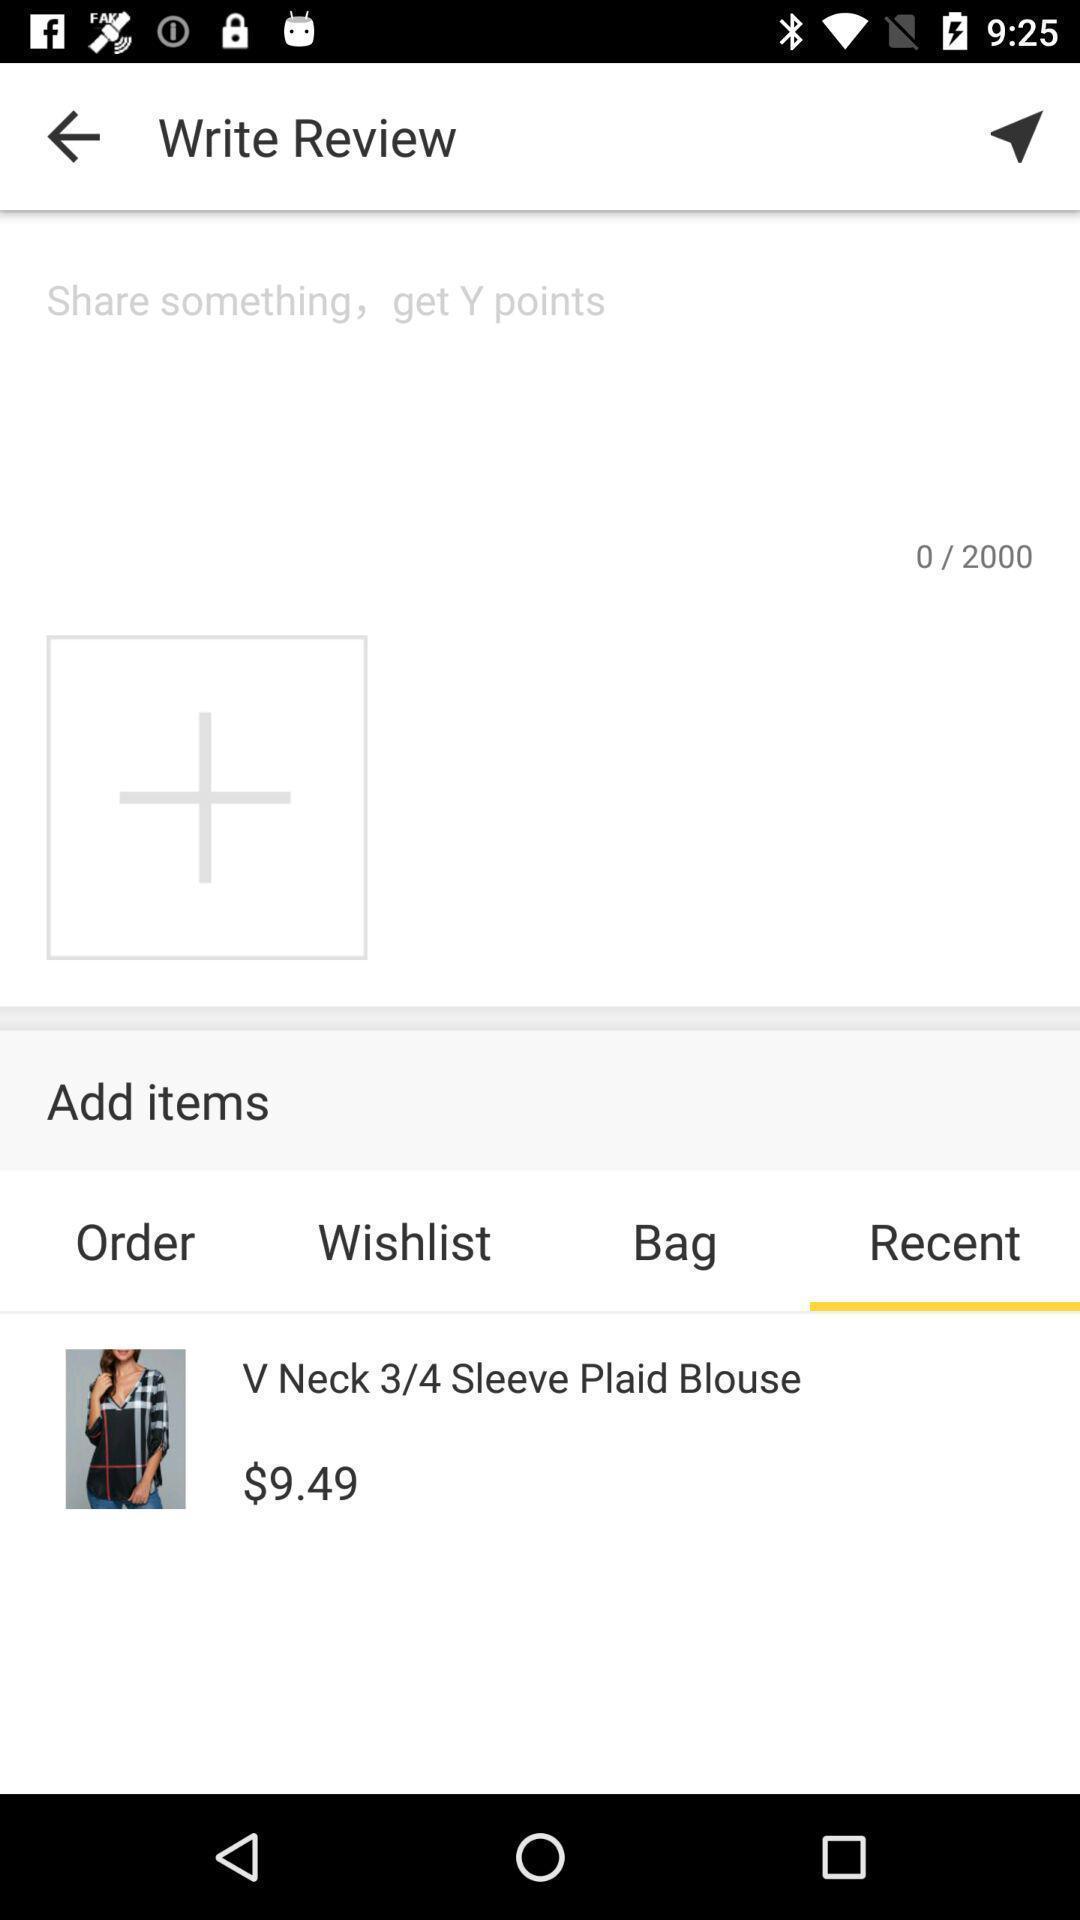Give me a narrative description of this picture. Screen displaying the recently added items on a shopping app. 